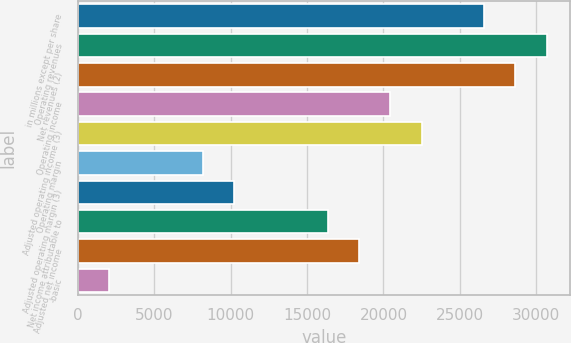Convert chart. <chart><loc_0><loc_0><loc_500><loc_500><bar_chart><fcel>in millions except per share<fcel>Operating revenues<fcel>Net revenues (2)<fcel>Operating income<fcel>Adjusted operating income (3)<fcel>Operating margin<fcel>Adjusted operating margin (3)<fcel>Net income attributable to<fcel>Adjusted net income<fcel>-basic<nl><fcel>26584.7<fcel>30674.5<fcel>28629.6<fcel>20450<fcel>22494.9<fcel>8180.57<fcel>10225.5<fcel>16360.2<fcel>18405.1<fcel>2045.87<nl></chart> 